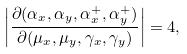Convert formula to latex. <formula><loc_0><loc_0><loc_500><loc_500>\left | \frac { \partial ( \alpha _ { x } , \alpha _ { y } , \alpha ^ { + } _ { x } , \alpha ^ { + } _ { y } ) } { \partial ( \mu _ { x } , \mu _ { y } , \gamma _ { x } , \gamma _ { y } ) } \right | = 4 ,</formula> 